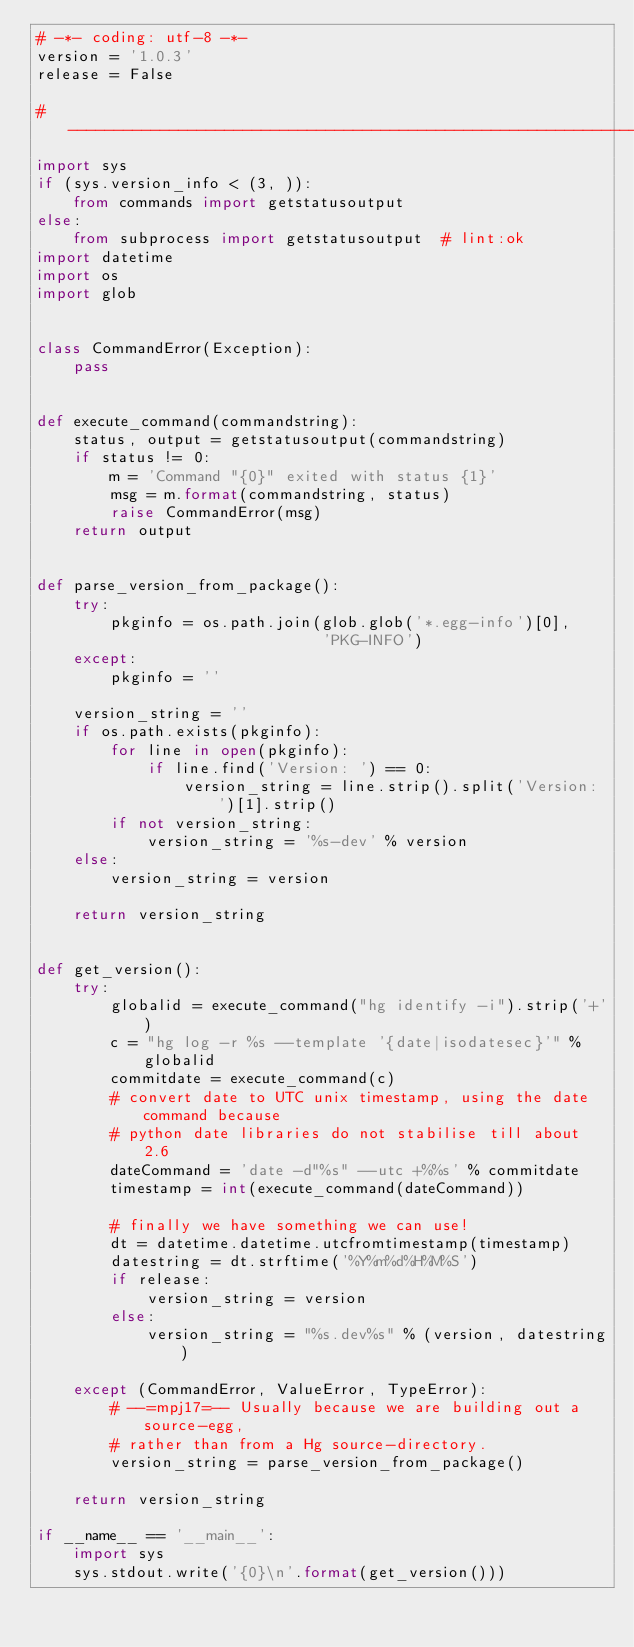<code> <loc_0><loc_0><loc_500><loc_500><_Python_># -*- coding: utf-8 -*-
version = '1.0.3'
release = False

#--------------------------------------------------------------------------#
import sys
if (sys.version_info < (3, )):
    from commands import getstatusoutput
else:
    from subprocess import getstatusoutput  # lint:ok
import datetime
import os
import glob


class CommandError(Exception):
    pass


def execute_command(commandstring):
    status, output = getstatusoutput(commandstring)
    if status != 0:
        m = 'Command "{0}" exited with status {1}'
        msg = m.format(commandstring, status)
        raise CommandError(msg)
    return output


def parse_version_from_package():
    try:
        pkginfo = os.path.join(glob.glob('*.egg-info')[0],
                               'PKG-INFO')
    except:
        pkginfo = ''

    version_string = ''
    if os.path.exists(pkginfo):
        for line in open(pkginfo):
            if line.find('Version: ') == 0:
                version_string = line.strip().split('Version: ')[1].strip()
        if not version_string:
            version_string = '%s-dev' % version
    else:
        version_string = version

    return version_string


def get_version():
    try:
        globalid = execute_command("hg identify -i").strip('+')
        c = "hg log -r %s --template '{date|isodatesec}'" % globalid
        commitdate = execute_command(c)
        # convert date to UTC unix timestamp, using the date command because
        # python date libraries do not stabilise till about 2.6
        dateCommand = 'date -d"%s" --utc +%%s' % commitdate
        timestamp = int(execute_command(dateCommand))

        # finally we have something we can use!
        dt = datetime.datetime.utcfromtimestamp(timestamp)
        datestring = dt.strftime('%Y%m%d%H%M%S')
        if release:
            version_string = version
        else:
            version_string = "%s.dev%s" % (version, datestring)

    except (CommandError, ValueError, TypeError):
        # --=mpj17=-- Usually because we are building out a source-egg,
        # rather than from a Hg source-directory.
        version_string = parse_version_from_package()

    return version_string

if __name__ == '__main__':
    import sys
    sys.stdout.write('{0}\n'.format(get_version()))
</code> 